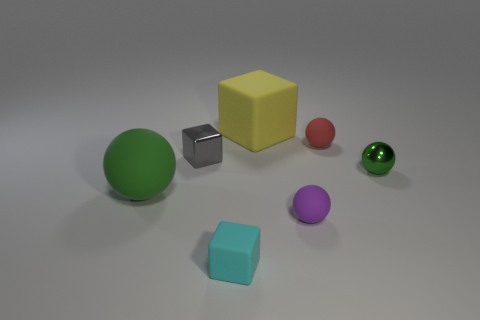Are there any other things that have the same material as the large block?
Provide a short and direct response. Yes. What is the cube that is behind the small green metallic thing and in front of the yellow cube made of?
Your answer should be very brief. Metal. What number of other tiny metallic things are the same shape as the tiny cyan thing?
Give a very brief answer. 1. What is the color of the small rubber sphere in front of the small block behind the tiny cyan matte object?
Ensure brevity in your answer.  Purple. Are there an equal number of big objects that are behind the red matte ball and large yellow matte objects?
Offer a very short reply. Yes. Is there another red matte sphere of the same size as the red rubber sphere?
Ensure brevity in your answer.  No. Does the gray metal cube have the same size as the green ball left of the gray shiny cube?
Offer a very short reply. No. Is the number of red rubber objects that are left of the cyan object the same as the number of tiny green balls that are in front of the big ball?
Keep it short and to the point. Yes. There is a small object in front of the purple matte sphere; what is it made of?
Offer a very short reply. Rubber. Do the red thing and the green matte sphere have the same size?
Provide a short and direct response. No. 